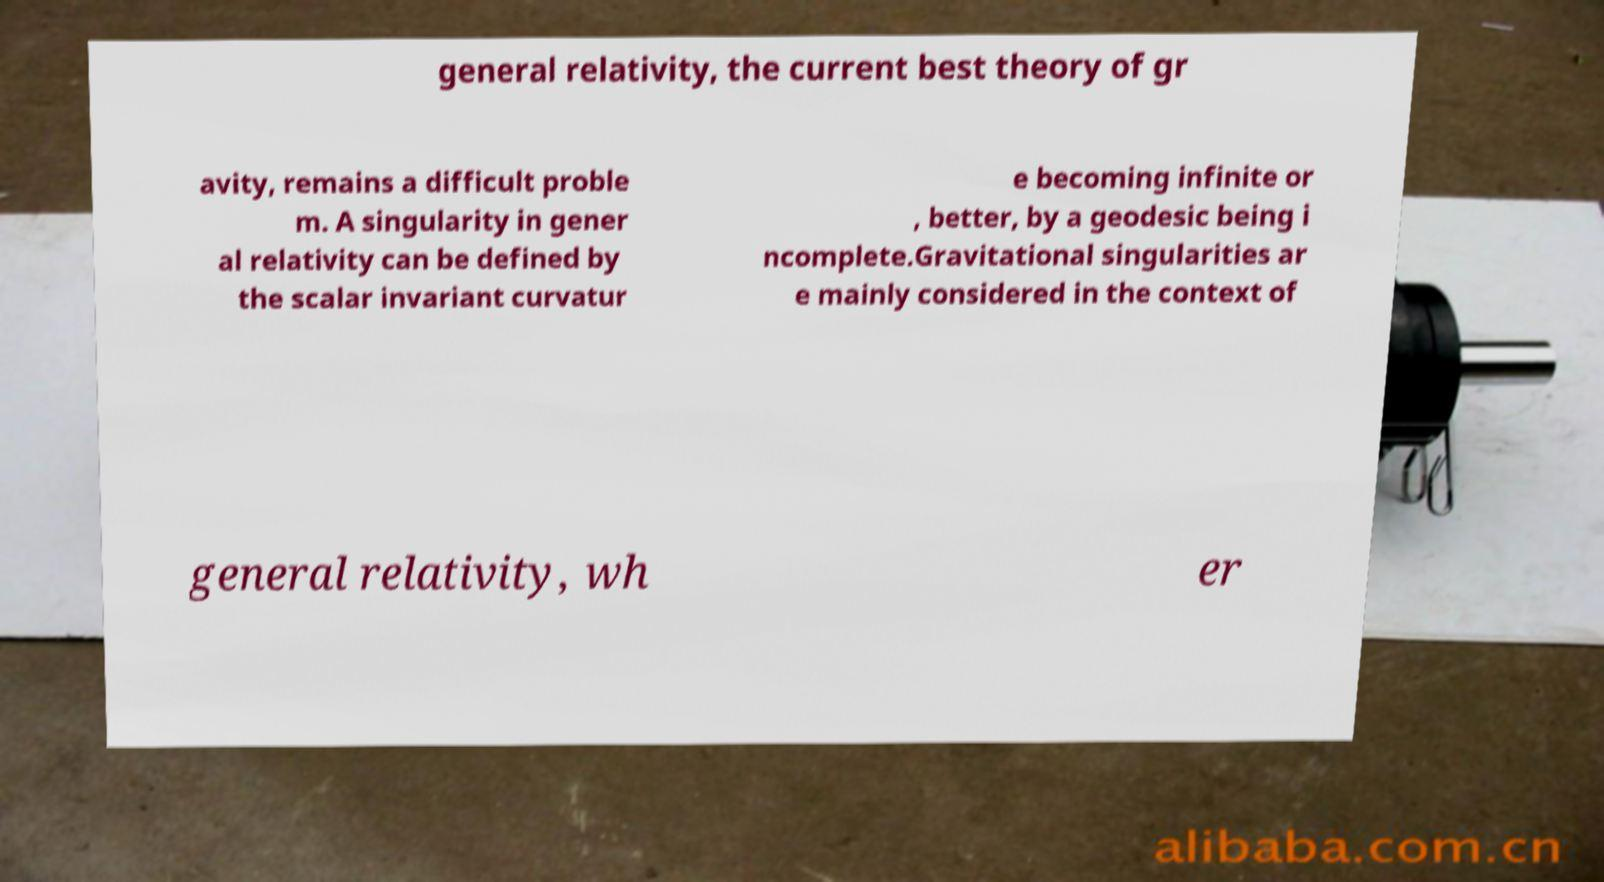Could you assist in decoding the text presented in this image and type it out clearly? general relativity, the current best theory of gr avity, remains a difficult proble m. A singularity in gener al relativity can be defined by the scalar invariant curvatur e becoming infinite or , better, by a geodesic being i ncomplete.Gravitational singularities ar e mainly considered in the context of general relativity, wh er 